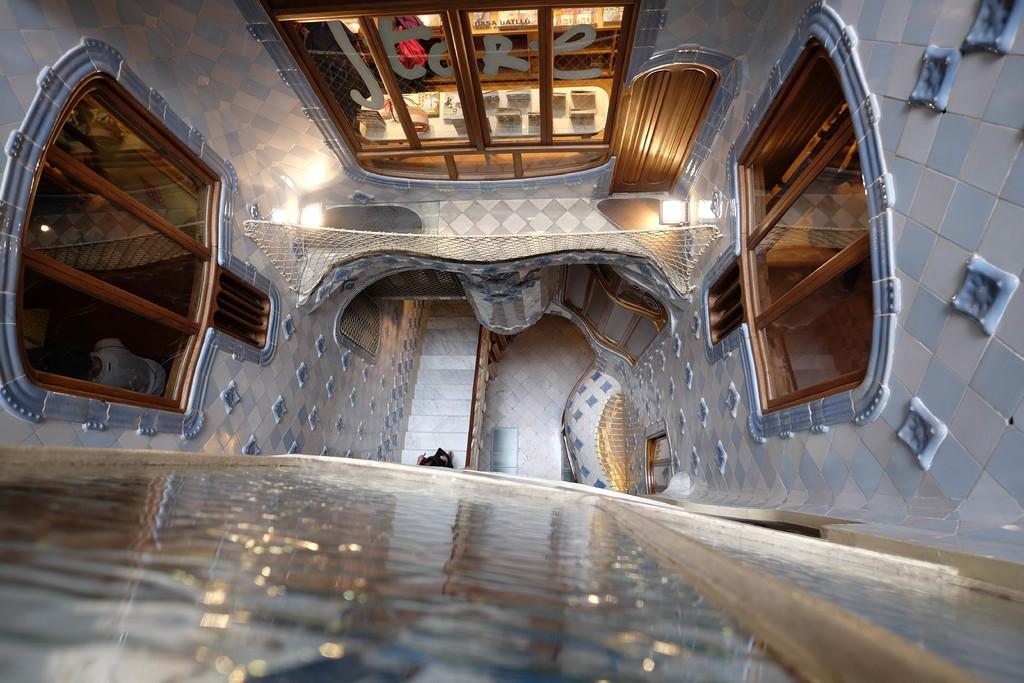What type of location is shown in the image? The image depicts the interior of a house. What architectural feature can be seen in the image? There are staircases in the image. What is a common feature of houses that is present in the image? There is a door in the image. What allows natural light to enter the house in the image? There are glass windows in the image. How many kittens are playing with the fuel in the image? There are no kittens or fuel present in the image. What is the tendency of the house in the image to lean to one side? The image does not show any indication of the house leaning to one side, and therefore it is not possible to determine its tendency. 